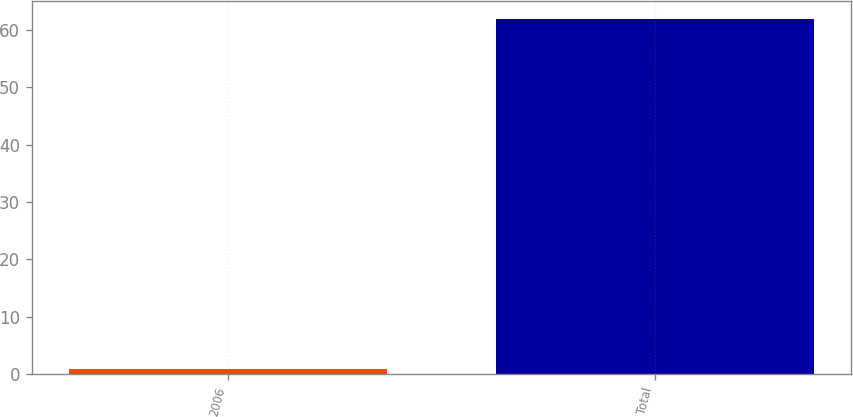Convert chart to OTSL. <chart><loc_0><loc_0><loc_500><loc_500><bar_chart><fcel>2006<fcel>Total<nl><fcel>0.9<fcel>62<nl></chart> 